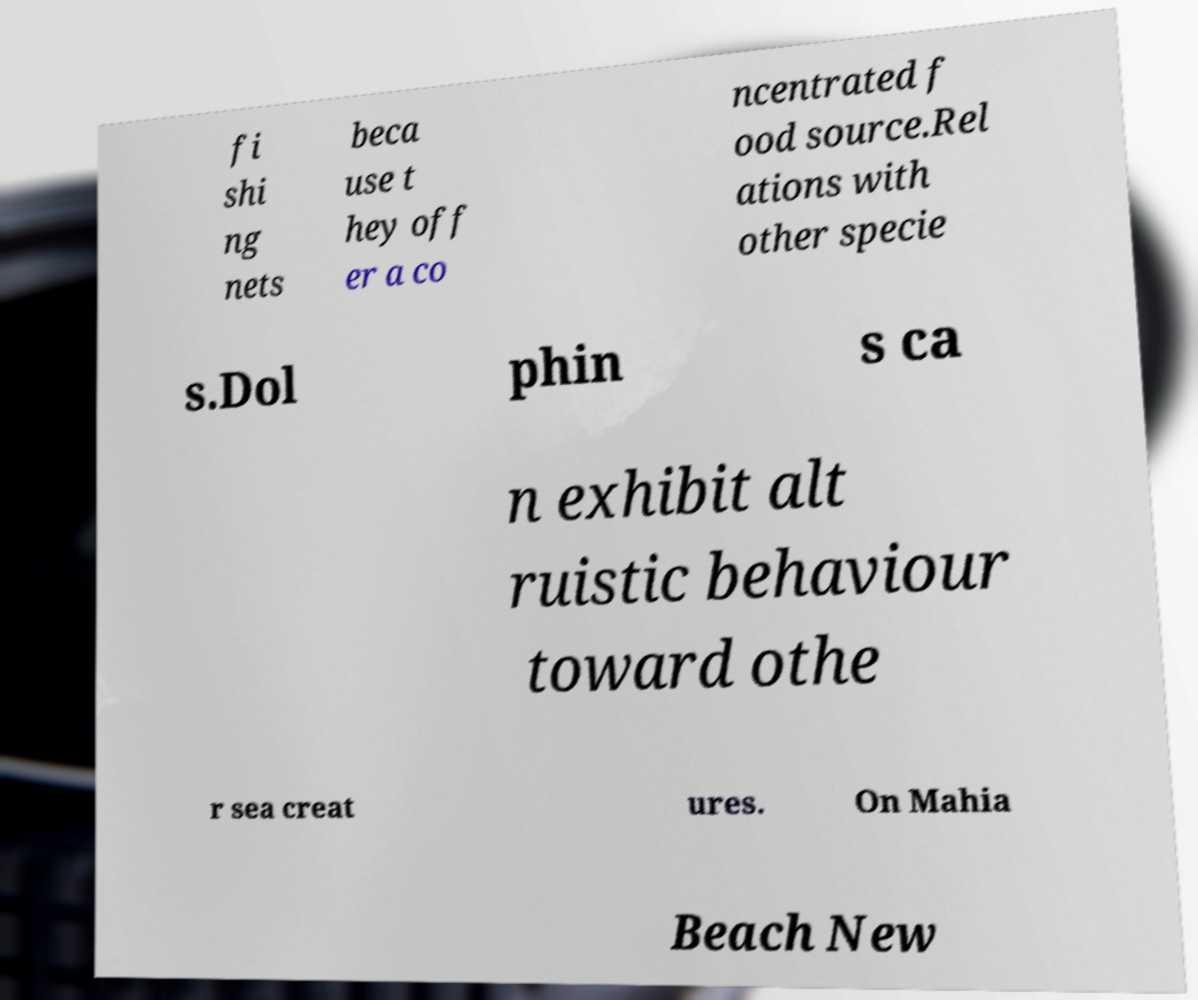What messages or text are displayed in this image? I need them in a readable, typed format. fi shi ng nets beca use t hey off er a co ncentrated f ood source.Rel ations with other specie s.Dol phin s ca n exhibit alt ruistic behaviour toward othe r sea creat ures. On Mahia Beach New 